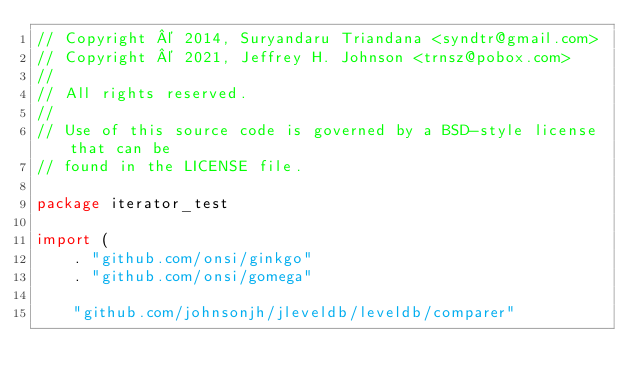Convert code to text. <code><loc_0><loc_0><loc_500><loc_500><_Go_>// Copyright © 2014, Suryandaru Triandana <syndtr@gmail.com>
// Copyright © 2021, Jeffrey H. Johnson <trnsz@pobox.com>
//
// All rights reserved.
//
// Use of this source code is governed by a BSD-style license that can be
// found in the LICENSE file.

package iterator_test

import (
	. "github.com/onsi/ginkgo"
	. "github.com/onsi/gomega"

	"github.com/johnsonjh/jleveldb/leveldb/comparer"</code> 